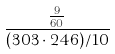Convert formula to latex. <formula><loc_0><loc_0><loc_500><loc_500>\frac { \frac { 9 } { 6 0 } } { ( 3 0 3 \cdot 2 4 6 ) / 1 0 }</formula> 